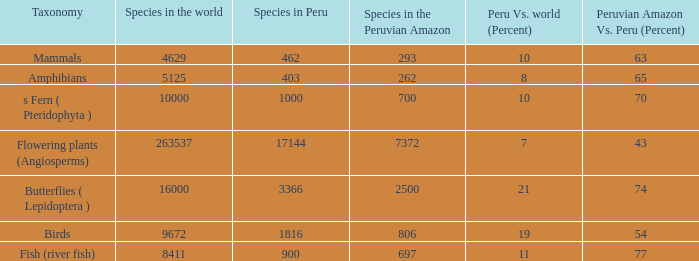What's the minimum species in the peruvian amazon with species in peru of 1000 700.0. 